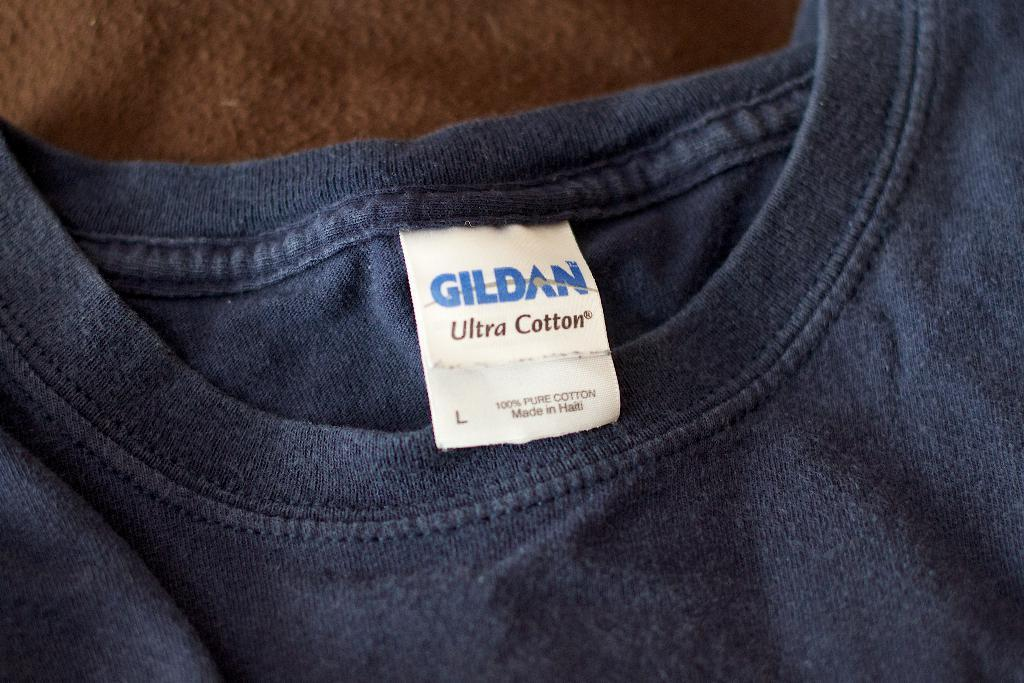What color is the t-shirt in the image? The t-shirt in the image is dark blue. Does the t-shirt have any additional features? Yes, the t-shirt has a tag. On what surface is the t-shirt placed? The t-shirt is placed on a brown color surface. What type of surprise is hidden inside the t-shirt in the image? There is no indication of a surprise hidden inside the t-shirt in the image. 